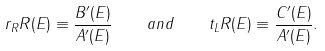<formula> <loc_0><loc_0><loc_500><loc_500>r _ { R } R ( E ) \equiv \frac { B ^ { \prime } ( E ) } { A ^ { \prime } ( E ) } \quad a n d \quad t _ { L } R ( E ) \equiv \frac { C ^ { \prime } ( E ) } { A ^ { \prime } ( E ) } .</formula> 